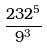Convert formula to latex. <formula><loc_0><loc_0><loc_500><loc_500>\frac { 2 3 2 ^ { 5 } } { 9 ^ { 3 } }</formula> 